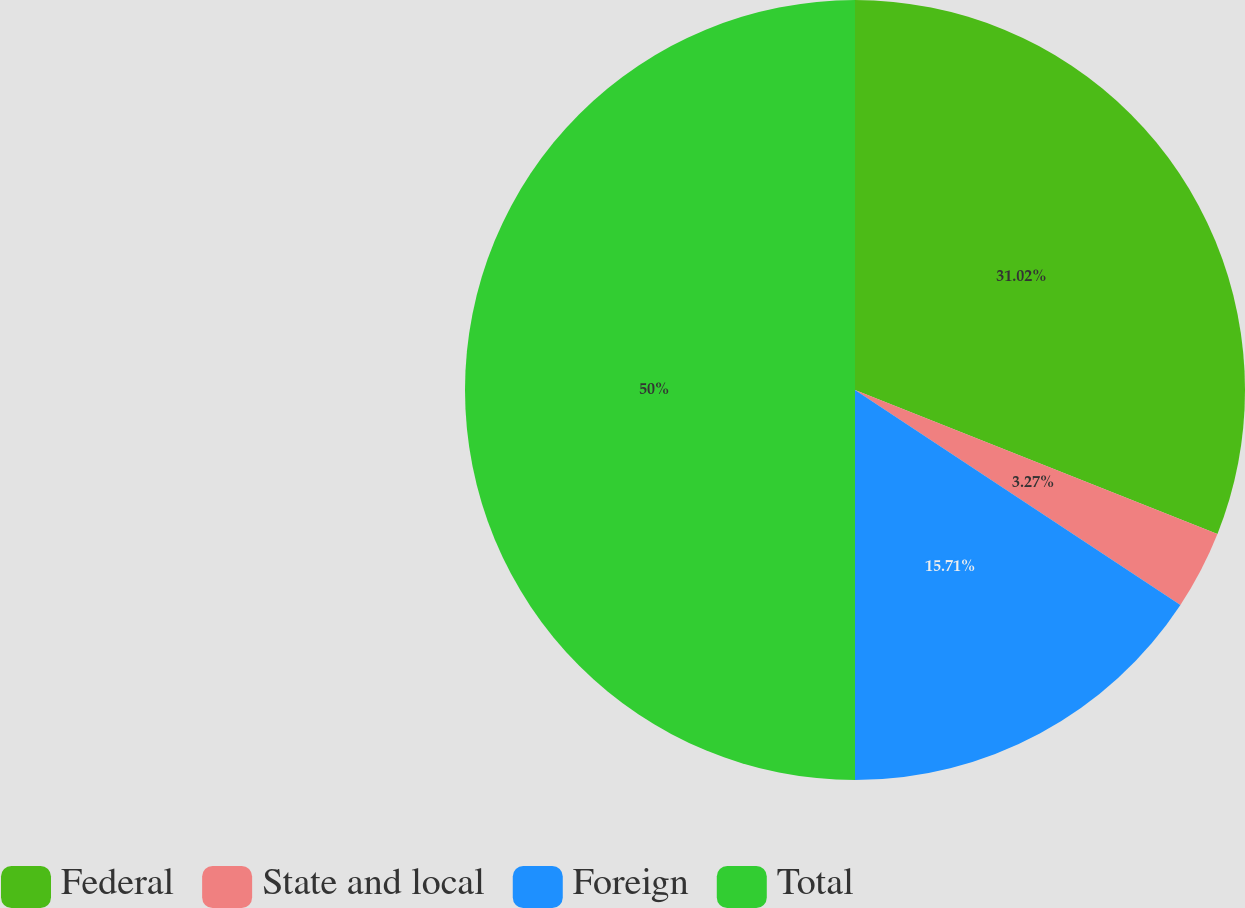Convert chart to OTSL. <chart><loc_0><loc_0><loc_500><loc_500><pie_chart><fcel>Federal<fcel>State and local<fcel>Foreign<fcel>Total<nl><fcel>31.02%<fcel>3.27%<fcel>15.71%<fcel>50.0%<nl></chart> 